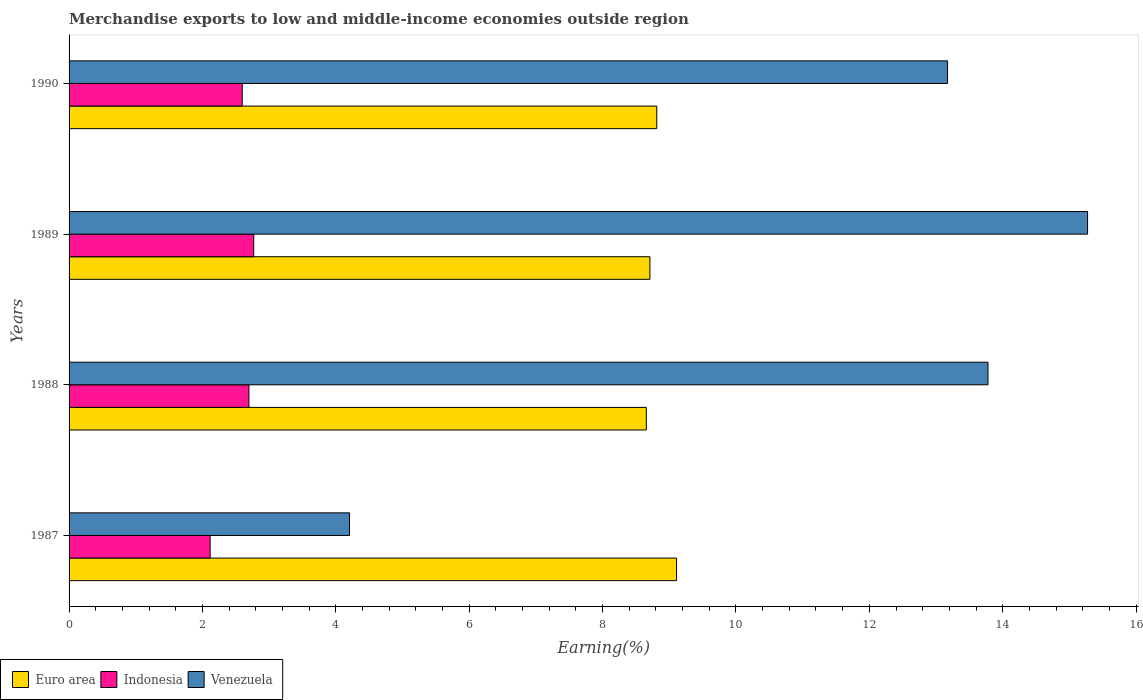How many different coloured bars are there?
Your response must be concise. 3. How many groups of bars are there?
Keep it short and to the point. 4. Are the number of bars on each tick of the Y-axis equal?
Keep it short and to the point. Yes. How many bars are there on the 1st tick from the top?
Make the answer very short. 3. What is the percentage of amount earned from merchandise exports in Venezuela in 1990?
Your answer should be very brief. 13.17. Across all years, what is the maximum percentage of amount earned from merchandise exports in Venezuela?
Give a very brief answer. 15.27. Across all years, what is the minimum percentage of amount earned from merchandise exports in Venezuela?
Offer a very short reply. 4.21. In which year was the percentage of amount earned from merchandise exports in Indonesia maximum?
Your answer should be very brief. 1989. In which year was the percentage of amount earned from merchandise exports in Euro area minimum?
Make the answer very short. 1988. What is the total percentage of amount earned from merchandise exports in Euro area in the graph?
Keep it short and to the point. 35.29. What is the difference between the percentage of amount earned from merchandise exports in Indonesia in 1987 and that in 1988?
Keep it short and to the point. -0.58. What is the difference between the percentage of amount earned from merchandise exports in Euro area in 1988 and the percentage of amount earned from merchandise exports in Indonesia in 1989?
Provide a succinct answer. 5.89. What is the average percentage of amount earned from merchandise exports in Euro area per year?
Keep it short and to the point. 8.82. In the year 1987, what is the difference between the percentage of amount earned from merchandise exports in Euro area and percentage of amount earned from merchandise exports in Venezuela?
Provide a short and direct response. 4.9. What is the ratio of the percentage of amount earned from merchandise exports in Venezuela in 1987 to that in 1989?
Your answer should be very brief. 0.28. Is the percentage of amount earned from merchandise exports in Venezuela in 1988 less than that in 1990?
Offer a very short reply. No. Is the difference between the percentage of amount earned from merchandise exports in Euro area in 1987 and 1989 greater than the difference between the percentage of amount earned from merchandise exports in Venezuela in 1987 and 1989?
Provide a short and direct response. Yes. What is the difference between the highest and the second highest percentage of amount earned from merchandise exports in Venezuela?
Your answer should be very brief. 1.49. What is the difference between the highest and the lowest percentage of amount earned from merchandise exports in Euro area?
Keep it short and to the point. 0.45. In how many years, is the percentage of amount earned from merchandise exports in Euro area greater than the average percentage of amount earned from merchandise exports in Euro area taken over all years?
Offer a terse response. 1. What does the 3rd bar from the bottom in 1990 represents?
Provide a succinct answer. Venezuela. Are all the bars in the graph horizontal?
Your answer should be very brief. Yes. Does the graph contain grids?
Make the answer very short. No. How many legend labels are there?
Provide a short and direct response. 3. How are the legend labels stacked?
Keep it short and to the point. Horizontal. What is the title of the graph?
Provide a succinct answer. Merchandise exports to low and middle-income economies outside region. Does "Paraguay" appear as one of the legend labels in the graph?
Your response must be concise. No. What is the label or title of the X-axis?
Your answer should be very brief. Earning(%). What is the label or title of the Y-axis?
Give a very brief answer. Years. What is the Earning(%) of Euro area in 1987?
Provide a short and direct response. 9.11. What is the Earning(%) of Indonesia in 1987?
Provide a short and direct response. 2.12. What is the Earning(%) of Venezuela in 1987?
Your answer should be very brief. 4.21. What is the Earning(%) in Euro area in 1988?
Provide a succinct answer. 8.66. What is the Earning(%) in Indonesia in 1988?
Provide a succinct answer. 2.7. What is the Earning(%) of Venezuela in 1988?
Keep it short and to the point. 13.78. What is the Earning(%) in Euro area in 1989?
Ensure brevity in your answer.  8.71. What is the Earning(%) in Indonesia in 1989?
Your answer should be very brief. 2.77. What is the Earning(%) of Venezuela in 1989?
Make the answer very short. 15.27. What is the Earning(%) of Euro area in 1990?
Give a very brief answer. 8.81. What is the Earning(%) of Indonesia in 1990?
Your response must be concise. 2.6. What is the Earning(%) of Venezuela in 1990?
Offer a terse response. 13.17. Across all years, what is the maximum Earning(%) in Euro area?
Your response must be concise. 9.11. Across all years, what is the maximum Earning(%) in Indonesia?
Offer a terse response. 2.77. Across all years, what is the maximum Earning(%) in Venezuela?
Provide a short and direct response. 15.27. Across all years, what is the minimum Earning(%) of Euro area?
Your answer should be very brief. 8.66. Across all years, what is the minimum Earning(%) in Indonesia?
Provide a short and direct response. 2.12. Across all years, what is the minimum Earning(%) in Venezuela?
Provide a short and direct response. 4.21. What is the total Earning(%) in Euro area in the graph?
Offer a very short reply. 35.29. What is the total Earning(%) of Indonesia in the graph?
Provide a succinct answer. 10.18. What is the total Earning(%) of Venezuela in the graph?
Give a very brief answer. 46.43. What is the difference between the Earning(%) in Euro area in 1987 and that in 1988?
Make the answer very short. 0.45. What is the difference between the Earning(%) of Indonesia in 1987 and that in 1988?
Offer a terse response. -0.58. What is the difference between the Earning(%) in Venezuela in 1987 and that in 1988?
Offer a very short reply. -9.57. What is the difference between the Earning(%) in Euro area in 1987 and that in 1989?
Your answer should be compact. 0.4. What is the difference between the Earning(%) of Indonesia in 1987 and that in 1989?
Provide a succinct answer. -0.65. What is the difference between the Earning(%) in Venezuela in 1987 and that in 1989?
Your answer should be compact. -11.07. What is the difference between the Earning(%) in Euro area in 1987 and that in 1990?
Offer a very short reply. 0.3. What is the difference between the Earning(%) in Indonesia in 1987 and that in 1990?
Offer a terse response. -0.48. What is the difference between the Earning(%) in Venezuela in 1987 and that in 1990?
Provide a succinct answer. -8.97. What is the difference between the Earning(%) in Euro area in 1988 and that in 1989?
Provide a short and direct response. -0.05. What is the difference between the Earning(%) in Indonesia in 1988 and that in 1989?
Your response must be concise. -0.07. What is the difference between the Earning(%) of Venezuela in 1988 and that in 1989?
Give a very brief answer. -1.49. What is the difference between the Earning(%) in Euro area in 1988 and that in 1990?
Keep it short and to the point. -0.16. What is the difference between the Earning(%) of Indonesia in 1988 and that in 1990?
Keep it short and to the point. 0.1. What is the difference between the Earning(%) in Venezuela in 1988 and that in 1990?
Your response must be concise. 0.61. What is the difference between the Earning(%) in Euro area in 1989 and that in 1990?
Provide a succinct answer. -0.1. What is the difference between the Earning(%) of Indonesia in 1989 and that in 1990?
Offer a very short reply. 0.17. What is the difference between the Earning(%) of Venezuela in 1989 and that in 1990?
Your answer should be compact. 2.1. What is the difference between the Earning(%) of Euro area in 1987 and the Earning(%) of Indonesia in 1988?
Your answer should be very brief. 6.41. What is the difference between the Earning(%) of Euro area in 1987 and the Earning(%) of Venezuela in 1988?
Give a very brief answer. -4.67. What is the difference between the Earning(%) of Indonesia in 1987 and the Earning(%) of Venezuela in 1988?
Offer a very short reply. -11.66. What is the difference between the Earning(%) in Euro area in 1987 and the Earning(%) in Indonesia in 1989?
Keep it short and to the point. 6.34. What is the difference between the Earning(%) in Euro area in 1987 and the Earning(%) in Venezuela in 1989?
Keep it short and to the point. -6.16. What is the difference between the Earning(%) in Indonesia in 1987 and the Earning(%) in Venezuela in 1989?
Your response must be concise. -13.16. What is the difference between the Earning(%) in Euro area in 1987 and the Earning(%) in Indonesia in 1990?
Give a very brief answer. 6.51. What is the difference between the Earning(%) of Euro area in 1987 and the Earning(%) of Venezuela in 1990?
Offer a terse response. -4.06. What is the difference between the Earning(%) of Indonesia in 1987 and the Earning(%) of Venezuela in 1990?
Make the answer very short. -11.06. What is the difference between the Earning(%) of Euro area in 1988 and the Earning(%) of Indonesia in 1989?
Your answer should be very brief. 5.89. What is the difference between the Earning(%) of Euro area in 1988 and the Earning(%) of Venezuela in 1989?
Keep it short and to the point. -6.62. What is the difference between the Earning(%) of Indonesia in 1988 and the Earning(%) of Venezuela in 1989?
Make the answer very short. -12.58. What is the difference between the Earning(%) in Euro area in 1988 and the Earning(%) in Indonesia in 1990?
Your answer should be very brief. 6.06. What is the difference between the Earning(%) in Euro area in 1988 and the Earning(%) in Venezuela in 1990?
Offer a very short reply. -4.52. What is the difference between the Earning(%) of Indonesia in 1988 and the Earning(%) of Venezuela in 1990?
Ensure brevity in your answer.  -10.48. What is the difference between the Earning(%) of Euro area in 1989 and the Earning(%) of Indonesia in 1990?
Provide a short and direct response. 6.11. What is the difference between the Earning(%) of Euro area in 1989 and the Earning(%) of Venezuela in 1990?
Keep it short and to the point. -4.46. What is the difference between the Earning(%) in Indonesia in 1989 and the Earning(%) in Venezuela in 1990?
Offer a terse response. -10.4. What is the average Earning(%) in Euro area per year?
Keep it short and to the point. 8.82. What is the average Earning(%) in Indonesia per year?
Your answer should be very brief. 2.54. What is the average Earning(%) of Venezuela per year?
Offer a very short reply. 11.61. In the year 1987, what is the difference between the Earning(%) in Euro area and Earning(%) in Indonesia?
Provide a succinct answer. 6.99. In the year 1987, what is the difference between the Earning(%) in Euro area and Earning(%) in Venezuela?
Provide a short and direct response. 4.9. In the year 1987, what is the difference between the Earning(%) in Indonesia and Earning(%) in Venezuela?
Offer a terse response. -2.09. In the year 1988, what is the difference between the Earning(%) of Euro area and Earning(%) of Indonesia?
Your answer should be very brief. 5.96. In the year 1988, what is the difference between the Earning(%) in Euro area and Earning(%) in Venezuela?
Make the answer very short. -5.12. In the year 1988, what is the difference between the Earning(%) of Indonesia and Earning(%) of Venezuela?
Give a very brief answer. -11.08. In the year 1989, what is the difference between the Earning(%) in Euro area and Earning(%) in Indonesia?
Ensure brevity in your answer.  5.94. In the year 1989, what is the difference between the Earning(%) in Euro area and Earning(%) in Venezuela?
Offer a very short reply. -6.56. In the year 1989, what is the difference between the Earning(%) in Indonesia and Earning(%) in Venezuela?
Your response must be concise. -12.5. In the year 1990, what is the difference between the Earning(%) in Euro area and Earning(%) in Indonesia?
Make the answer very short. 6.22. In the year 1990, what is the difference between the Earning(%) in Euro area and Earning(%) in Venezuela?
Provide a short and direct response. -4.36. In the year 1990, what is the difference between the Earning(%) in Indonesia and Earning(%) in Venezuela?
Offer a terse response. -10.58. What is the ratio of the Earning(%) in Euro area in 1987 to that in 1988?
Give a very brief answer. 1.05. What is the ratio of the Earning(%) in Indonesia in 1987 to that in 1988?
Your answer should be compact. 0.78. What is the ratio of the Earning(%) in Venezuela in 1987 to that in 1988?
Your response must be concise. 0.31. What is the ratio of the Earning(%) in Euro area in 1987 to that in 1989?
Ensure brevity in your answer.  1.05. What is the ratio of the Earning(%) in Indonesia in 1987 to that in 1989?
Your answer should be compact. 0.76. What is the ratio of the Earning(%) of Venezuela in 1987 to that in 1989?
Make the answer very short. 0.28. What is the ratio of the Earning(%) in Euro area in 1987 to that in 1990?
Make the answer very short. 1.03. What is the ratio of the Earning(%) in Indonesia in 1987 to that in 1990?
Provide a succinct answer. 0.81. What is the ratio of the Earning(%) in Venezuela in 1987 to that in 1990?
Your answer should be very brief. 0.32. What is the ratio of the Earning(%) of Euro area in 1988 to that in 1989?
Offer a very short reply. 0.99. What is the ratio of the Earning(%) in Indonesia in 1988 to that in 1989?
Ensure brevity in your answer.  0.97. What is the ratio of the Earning(%) in Venezuela in 1988 to that in 1989?
Give a very brief answer. 0.9. What is the ratio of the Earning(%) in Euro area in 1988 to that in 1990?
Ensure brevity in your answer.  0.98. What is the ratio of the Earning(%) in Indonesia in 1988 to that in 1990?
Keep it short and to the point. 1.04. What is the ratio of the Earning(%) in Venezuela in 1988 to that in 1990?
Keep it short and to the point. 1.05. What is the ratio of the Earning(%) in Euro area in 1989 to that in 1990?
Provide a short and direct response. 0.99. What is the ratio of the Earning(%) of Indonesia in 1989 to that in 1990?
Offer a very short reply. 1.07. What is the ratio of the Earning(%) of Venezuela in 1989 to that in 1990?
Offer a terse response. 1.16. What is the difference between the highest and the second highest Earning(%) of Euro area?
Offer a very short reply. 0.3. What is the difference between the highest and the second highest Earning(%) of Indonesia?
Ensure brevity in your answer.  0.07. What is the difference between the highest and the second highest Earning(%) of Venezuela?
Provide a succinct answer. 1.49. What is the difference between the highest and the lowest Earning(%) of Euro area?
Your response must be concise. 0.45. What is the difference between the highest and the lowest Earning(%) of Indonesia?
Your response must be concise. 0.65. What is the difference between the highest and the lowest Earning(%) of Venezuela?
Provide a succinct answer. 11.07. 